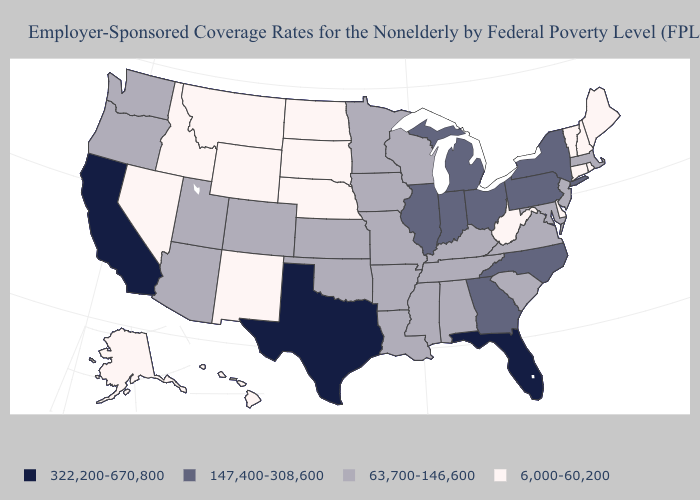What is the highest value in the USA?
Be succinct. 322,200-670,800. Does the map have missing data?
Concise answer only. No. Among the states that border Texas , which have the highest value?
Keep it brief. Arkansas, Louisiana, Oklahoma. Among the states that border Idaho , which have the highest value?
Concise answer only. Oregon, Utah, Washington. Name the states that have a value in the range 6,000-60,200?
Answer briefly. Alaska, Connecticut, Delaware, Hawaii, Idaho, Maine, Montana, Nebraska, Nevada, New Hampshire, New Mexico, North Dakota, Rhode Island, South Dakota, Vermont, West Virginia, Wyoming. Name the states that have a value in the range 6,000-60,200?
Write a very short answer. Alaska, Connecticut, Delaware, Hawaii, Idaho, Maine, Montana, Nebraska, Nevada, New Hampshire, New Mexico, North Dakota, Rhode Island, South Dakota, Vermont, West Virginia, Wyoming. What is the lowest value in the MidWest?
Answer briefly. 6,000-60,200. Which states have the lowest value in the USA?
Concise answer only. Alaska, Connecticut, Delaware, Hawaii, Idaho, Maine, Montana, Nebraska, Nevada, New Hampshire, New Mexico, North Dakota, Rhode Island, South Dakota, Vermont, West Virginia, Wyoming. What is the value of Mississippi?
Be succinct. 63,700-146,600. Among the states that border Vermont , which have the lowest value?
Concise answer only. New Hampshire. Among the states that border Nebraska , which have the highest value?
Keep it brief. Colorado, Iowa, Kansas, Missouri. Name the states that have a value in the range 147,400-308,600?
Quick response, please. Georgia, Illinois, Indiana, Michigan, New York, North Carolina, Ohio, Pennsylvania. Name the states that have a value in the range 6,000-60,200?
Quick response, please. Alaska, Connecticut, Delaware, Hawaii, Idaho, Maine, Montana, Nebraska, Nevada, New Hampshire, New Mexico, North Dakota, Rhode Island, South Dakota, Vermont, West Virginia, Wyoming. What is the value of West Virginia?
Give a very brief answer. 6,000-60,200. What is the value of Mississippi?
Concise answer only. 63,700-146,600. 